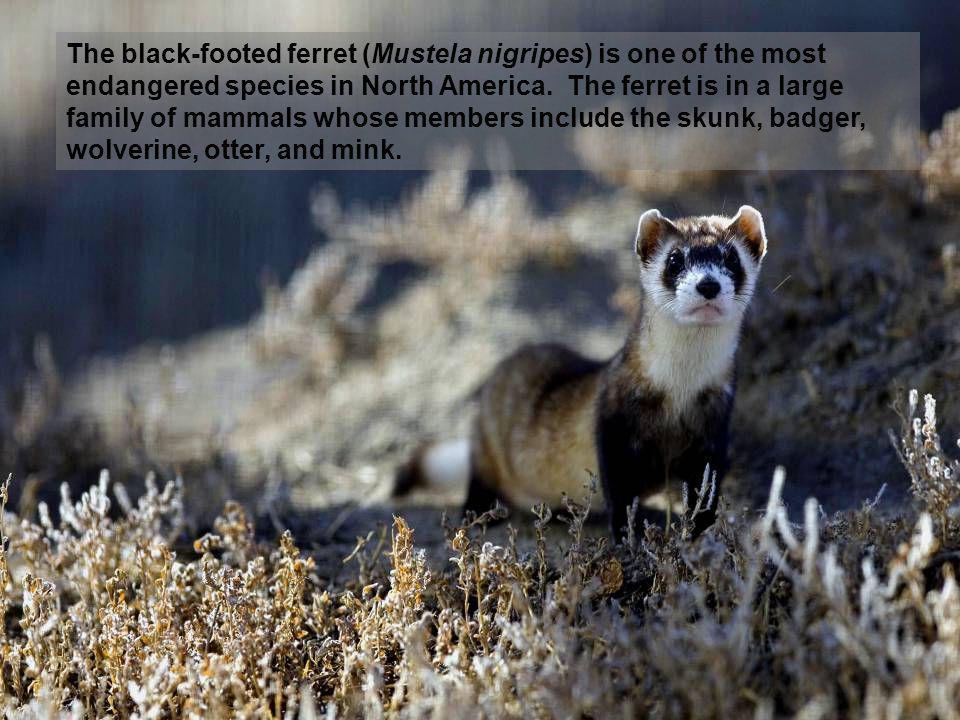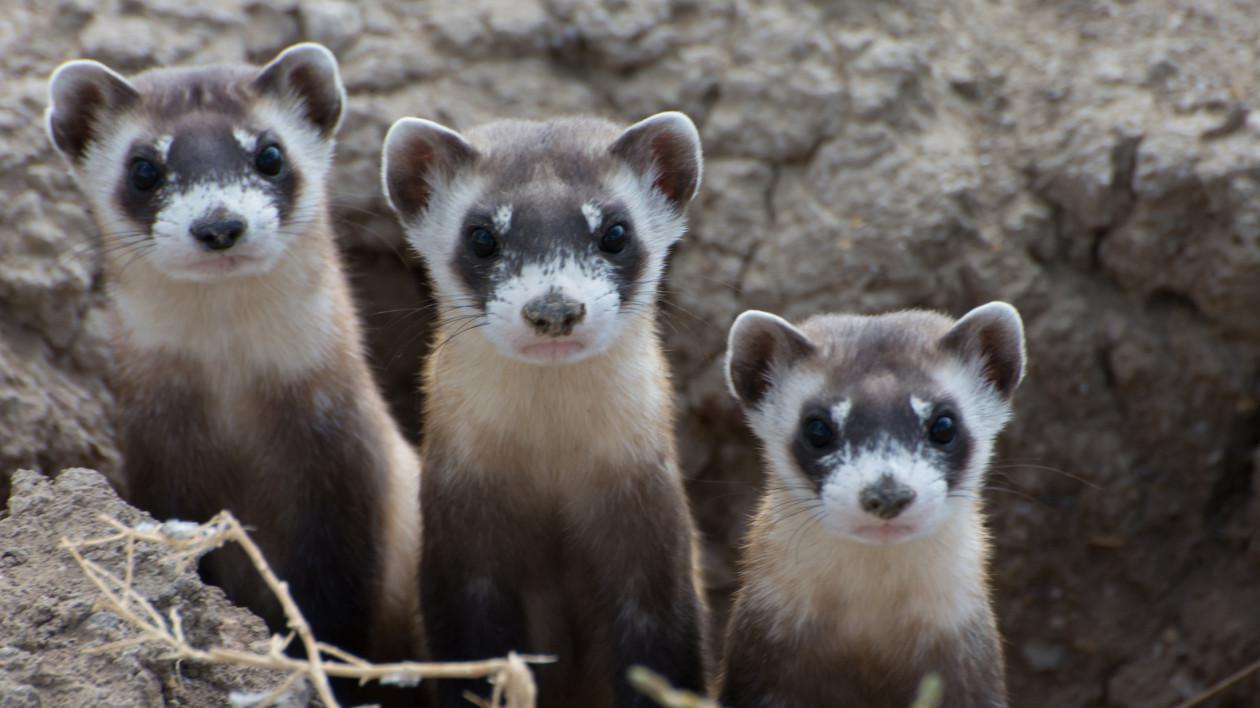The first image is the image on the left, the second image is the image on the right. Evaluate the accuracy of this statement regarding the images: "There are more animals in the image on the right.". Is it true? Answer yes or no. Yes. The first image is the image on the left, the second image is the image on the right. Considering the images on both sides, is "The right image contains at least two ferrets." valid? Answer yes or no. Yes. 